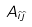Convert formula to latex. <formula><loc_0><loc_0><loc_500><loc_500>A _ { { \hat { \imath } } { \hat { \jmath } } }</formula> 